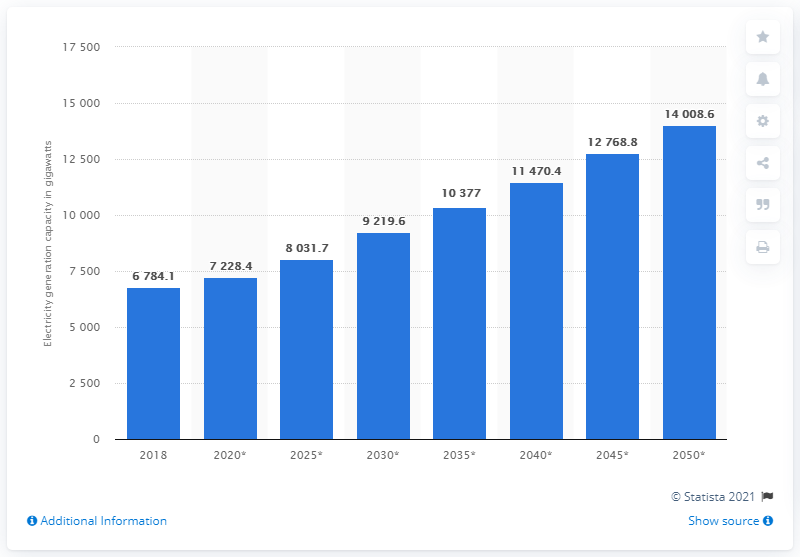Mention a couple of crucial points in this snapshot. In 2018, the world's electricity generation capacity was measured. 